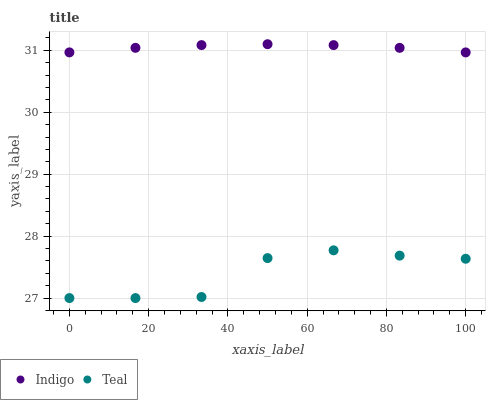Does Teal have the minimum area under the curve?
Answer yes or no. Yes. Does Indigo have the maximum area under the curve?
Answer yes or no. Yes. Does Teal have the maximum area under the curve?
Answer yes or no. No. Is Indigo the smoothest?
Answer yes or no. Yes. Is Teal the roughest?
Answer yes or no. Yes. Is Teal the smoothest?
Answer yes or no. No. Does Teal have the lowest value?
Answer yes or no. Yes. Does Indigo have the highest value?
Answer yes or no. Yes. Does Teal have the highest value?
Answer yes or no. No. Is Teal less than Indigo?
Answer yes or no. Yes. Is Indigo greater than Teal?
Answer yes or no. Yes. Does Teal intersect Indigo?
Answer yes or no. No. 